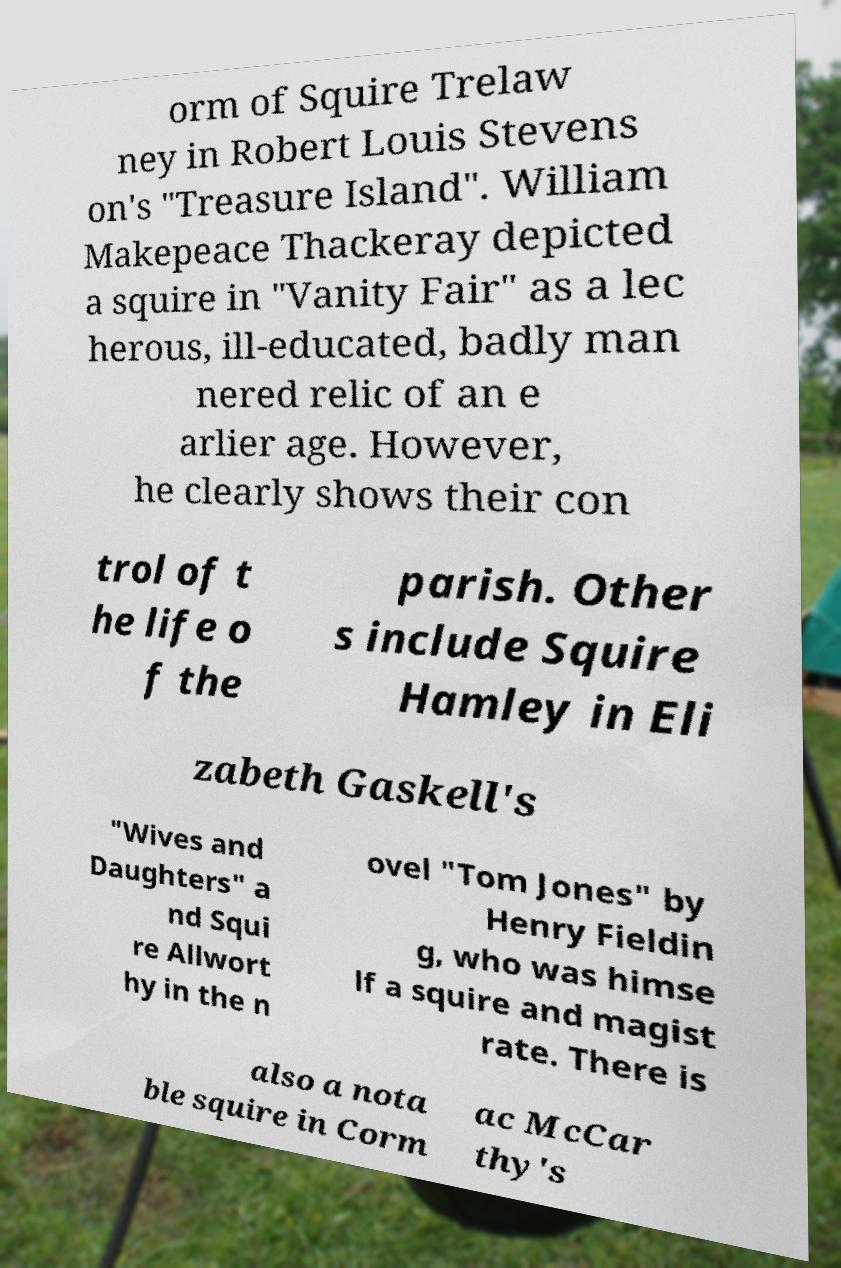What messages or text are displayed in this image? I need them in a readable, typed format. orm of Squire Trelaw ney in Robert Louis Stevens on's "Treasure Island". William Makepeace Thackeray depicted a squire in "Vanity Fair" as a lec herous, ill-educated, badly man nered relic of an e arlier age. However, he clearly shows their con trol of t he life o f the parish. Other s include Squire Hamley in Eli zabeth Gaskell's "Wives and Daughters" a nd Squi re Allwort hy in the n ovel "Tom Jones" by Henry Fieldin g, who was himse lf a squire and magist rate. There is also a nota ble squire in Corm ac McCar thy's 